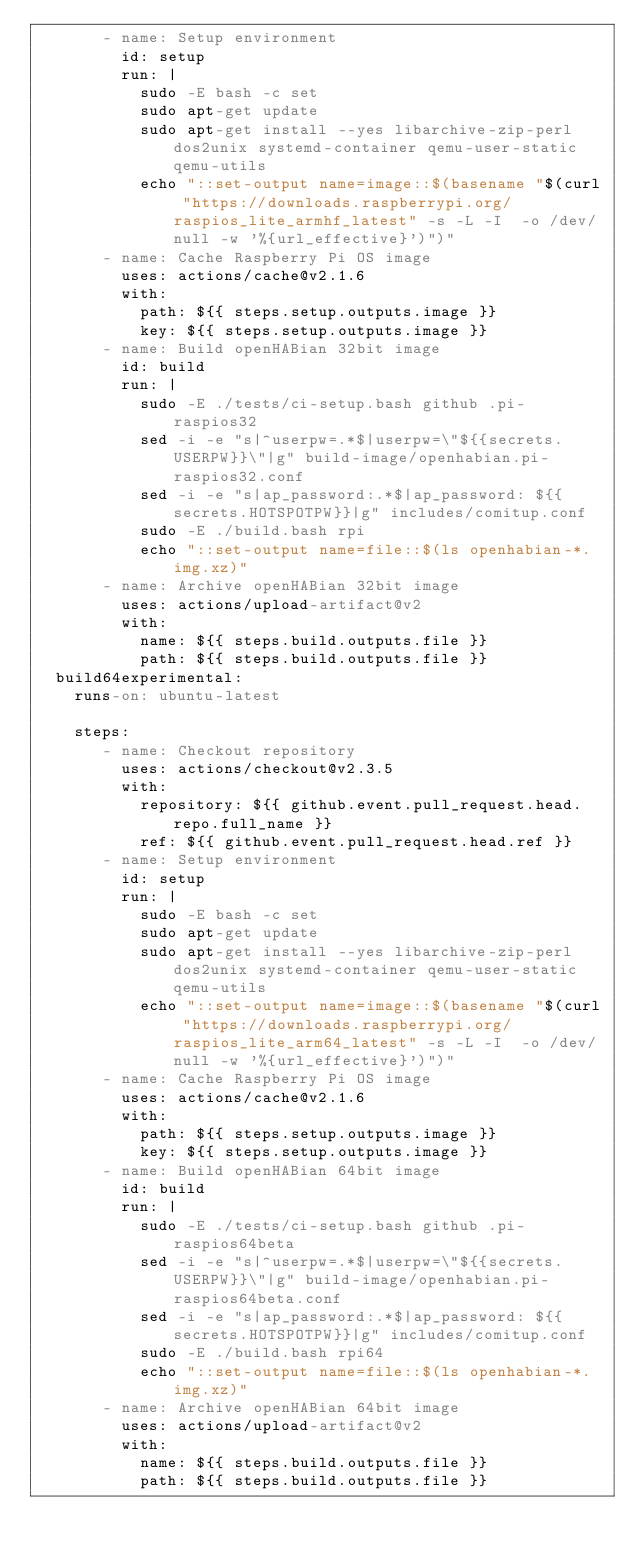Convert code to text. <code><loc_0><loc_0><loc_500><loc_500><_YAML_>       - name: Setup environment
         id: setup
         run: |
           sudo -E bash -c set
           sudo apt-get update
           sudo apt-get install --yes libarchive-zip-perl dos2unix systemd-container qemu-user-static qemu-utils
           echo "::set-output name=image::$(basename "$(curl "https://downloads.raspberrypi.org/raspios_lite_armhf_latest" -s -L -I  -o /dev/null -w '%{url_effective}')")"
       - name: Cache Raspberry Pi OS image
         uses: actions/cache@v2.1.6
         with:
           path: ${{ steps.setup.outputs.image }}
           key: ${{ steps.setup.outputs.image }}
       - name: Build openHABian 32bit image
         id: build
         run: |
           sudo -E ./tests/ci-setup.bash github .pi-raspios32
           sed -i -e "s|^userpw=.*$|userpw=\"${{secrets.USERPW}}\"|g" build-image/openhabian.pi-raspios32.conf
           sed -i -e "s|ap_password:.*$|ap_password: ${{secrets.HOTSPOTPW}}|g" includes/comitup.conf
           sudo -E ./build.bash rpi
           echo "::set-output name=file::$(ls openhabian-*.img.xz)"
       - name: Archive openHABian 32bit image
         uses: actions/upload-artifact@v2
         with:
           name: ${{ steps.build.outputs.file }}
           path: ${{ steps.build.outputs.file }}
  build64experimental:
    runs-on: ubuntu-latest

    steps:
       - name: Checkout repository
         uses: actions/checkout@v2.3.5
         with:
           repository: ${{ github.event.pull_request.head.repo.full_name }}
           ref: ${{ github.event.pull_request.head.ref }}
       - name: Setup environment
         id: setup
         run: |
           sudo -E bash -c set
           sudo apt-get update
           sudo apt-get install --yes libarchive-zip-perl dos2unix systemd-container qemu-user-static qemu-utils
           echo "::set-output name=image::$(basename "$(curl "https://downloads.raspberrypi.org/raspios_lite_arm64_latest" -s -L -I  -o /dev/null -w '%{url_effective}')")"
       - name: Cache Raspberry Pi OS image
         uses: actions/cache@v2.1.6
         with:
           path: ${{ steps.setup.outputs.image }}
           key: ${{ steps.setup.outputs.image }}
       - name: Build openHABian 64bit image
         id: build
         run: |
           sudo -E ./tests/ci-setup.bash github .pi-raspios64beta
           sed -i -e "s|^userpw=.*$|userpw=\"${{secrets.USERPW}}\"|g" build-image/openhabian.pi-raspios64beta.conf
           sed -i -e "s|ap_password:.*$|ap_password: ${{secrets.HOTSPOTPW}}|g" includes/comitup.conf
           sudo -E ./build.bash rpi64
           echo "::set-output name=file::$(ls openhabian-*.img.xz)"
       - name: Archive openHABian 64bit image
         uses: actions/upload-artifact@v2
         with:
           name: ${{ steps.build.outputs.file }}
           path: ${{ steps.build.outputs.file }}
</code> 